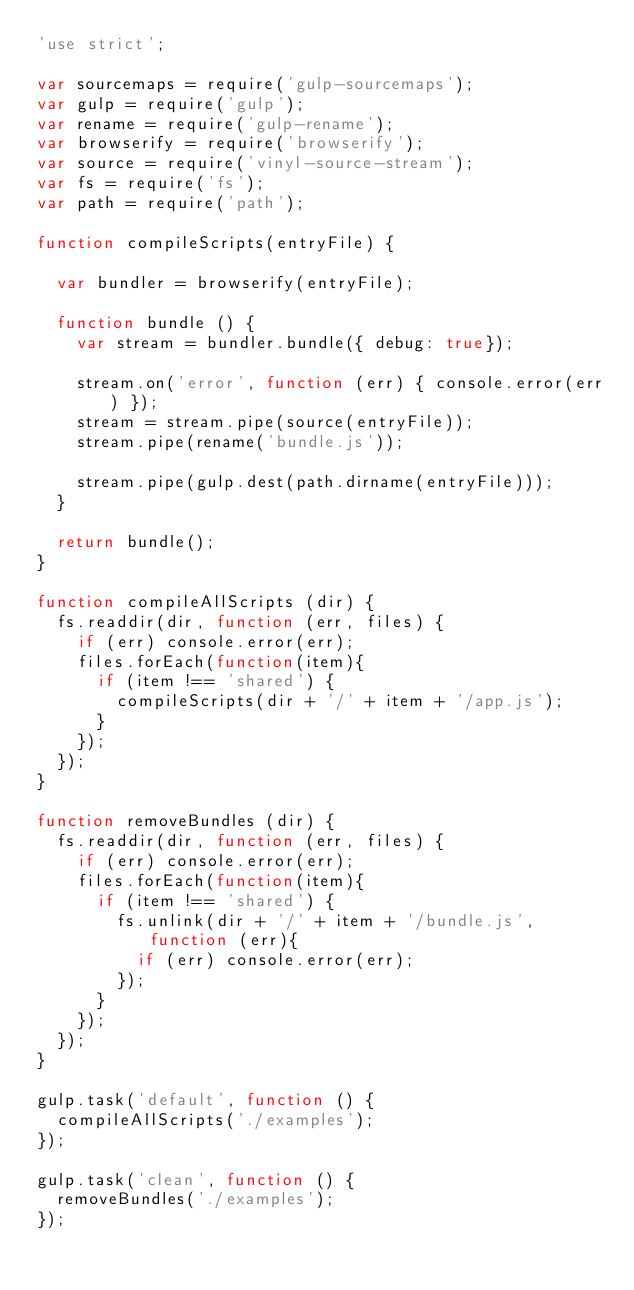<code> <loc_0><loc_0><loc_500><loc_500><_JavaScript_>'use strict';

var sourcemaps = require('gulp-sourcemaps');
var gulp = require('gulp');
var rename = require('gulp-rename');
var browserify = require('browserify');
var source = require('vinyl-source-stream');
var fs = require('fs');
var path = require('path');

function compileScripts(entryFile) {

  var bundler = browserify(entryFile);

  function bundle () {
    var stream = bundler.bundle({ debug: true});

    stream.on('error', function (err) { console.error(err) });
    stream = stream.pipe(source(entryFile));
    stream.pipe(rename('bundle.js'));

    stream.pipe(gulp.dest(path.dirname(entryFile)));
  }

  return bundle();
}

function compileAllScripts (dir) {
  fs.readdir(dir, function (err, files) { 
    if (err) console.error(err);
    files.forEach(function(item){
      if (item !== 'shared') {
        compileScripts(dir + '/' + item + '/app.js');
      }
    });
  });
}

function removeBundles (dir) {
  fs.readdir(dir, function (err, files) { 
    if (err) console.error(err);
    files.forEach(function(item){
      if (item !== 'shared') {
        fs.unlink(dir + '/' + item + '/bundle.js', function (err){
          if (err) console.error(err);
        });
      }
    });
  });
}

gulp.task('default', function () {
  compileAllScripts('./examples');
});

gulp.task('clean', function () {
  removeBundles('./examples');
});
</code> 